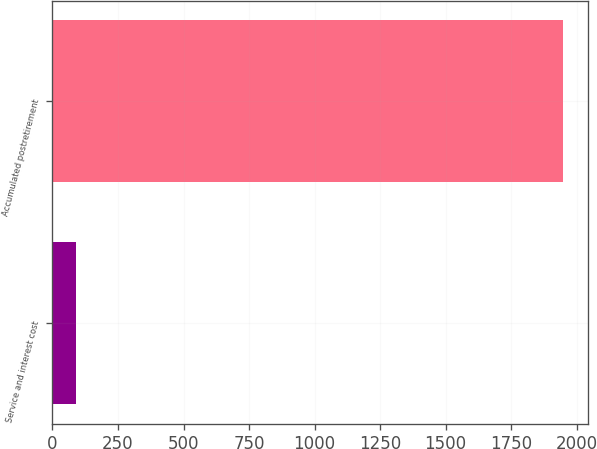<chart> <loc_0><loc_0><loc_500><loc_500><bar_chart><fcel>Service and interest cost<fcel>Accumulated postretirement<nl><fcel>91<fcel>1947<nl></chart> 